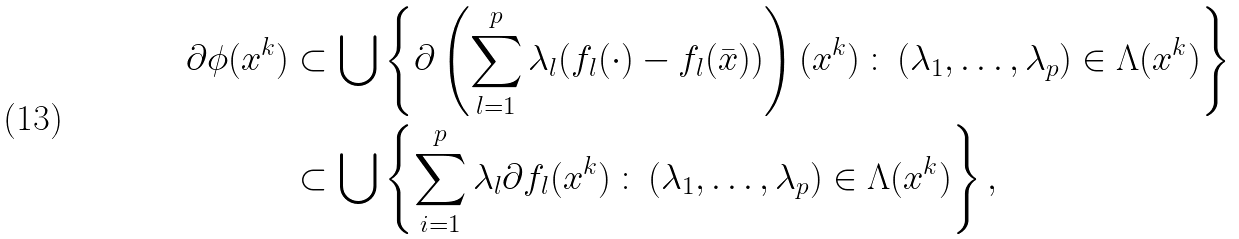Convert formula to latex. <formula><loc_0><loc_0><loc_500><loc_500>\partial \phi ( x ^ { k } ) & \subset \bigcup \left \{ \partial \left ( \sum _ { l = 1 } ^ { p } \lambda _ { l } ( f _ { l } ( \cdot ) - f _ { l } ( \bar { x } ) ) \right ) ( x ^ { k } ) \, \colon \, ( \lambda _ { 1 } , \dots , \lambda _ { p } ) \in \Lambda ( x ^ { k } ) \right \} \\ & \subset \bigcup \left \{ \sum _ { i = 1 } ^ { p } \lambda _ { l } \partial f _ { l } ( x ^ { k } ) \, \colon \, ( \lambda _ { 1 } , \dots , \lambda _ { p } ) \in \Lambda ( x ^ { k } ) \right \} ,</formula> 